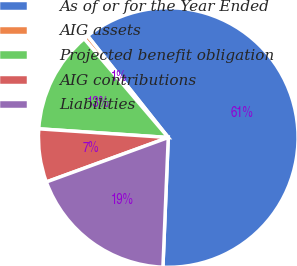<chart> <loc_0><loc_0><loc_500><loc_500><pie_chart><fcel>As of or for the Year Ended<fcel>AIG assets<fcel>Projected benefit obligation<fcel>AIG contributions<fcel>Liabilities<nl><fcel>61.33%<fcel>0.55%<fcel>12.71%<fcel>6.63%<fcel>18.78%<nl></chart> 